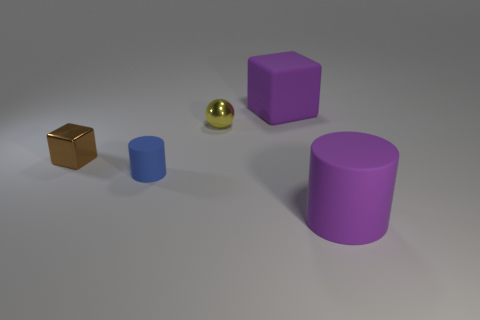Add 2 brown rubber cubes. How many objects exist? 7 Subtract all spheres. How many objects are left? 4 Add 2 blocks. How many blocks exist? 4 Subtract 0 purple balls. How many objects are left? 5 Subtract all large gray metallic spheres. Subtract all small blue cylinders. How many objects are left? 4 Add 5 small blue objects. How many small blue objects are left? 6 